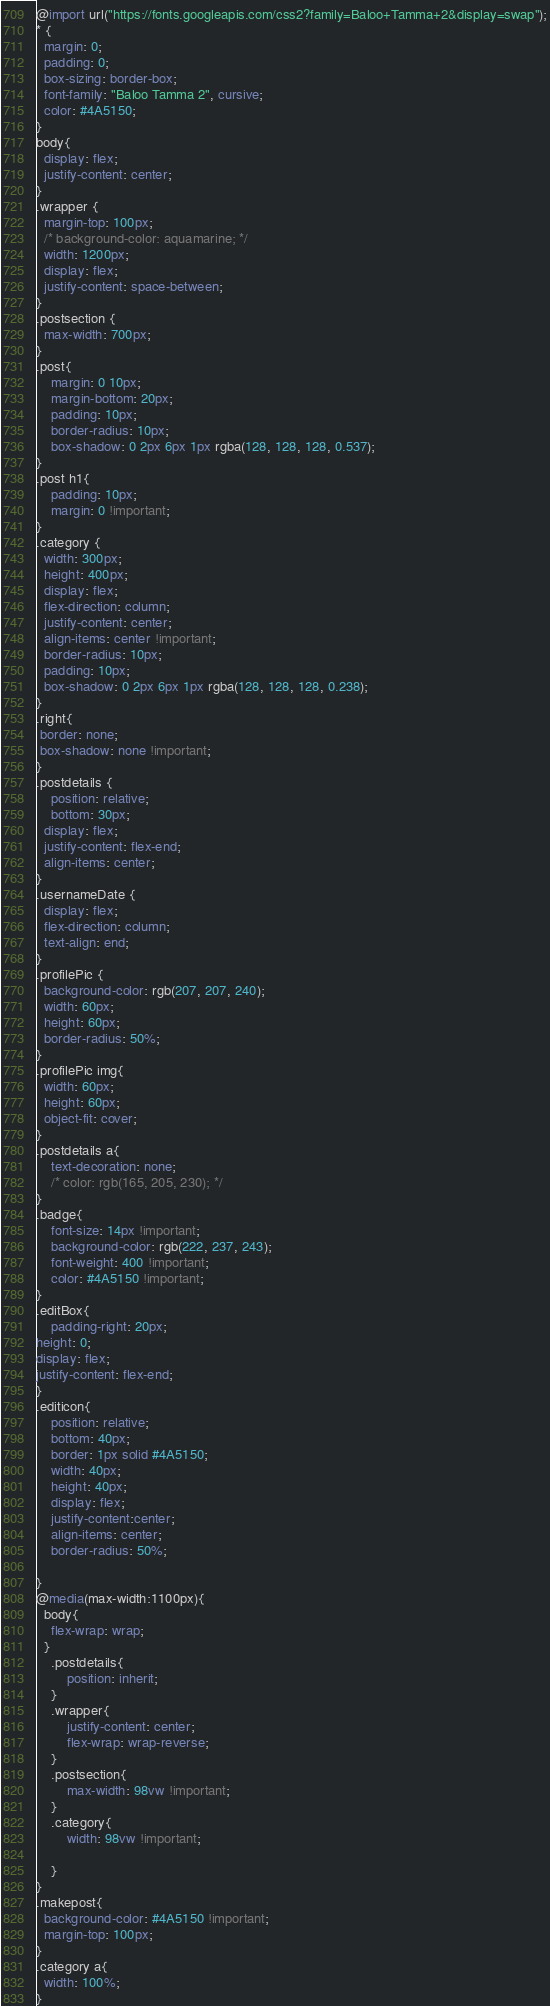Convert code to text. <code><loc_0><loc_0><loc_500><loc_500><_CSS_>@import url("https://fonts.googleapis.com/css2?family=Baloo+Tamma+2&display=swap");
* {
  margin: 0;
  padding: 0;
  box-sizing: border-box;
  font-family: "Baloo Tamma 2", cursive;
  color: #4A5150;
}
body{
  display: flex;
  justify-content: center;
}
.wrapper {
  margin-top: 100px;
  /* background-color: aquamarine; */
  width: 1200px;
  display: flex;
  justify-content: space-between;
}
.postsection {
  max-width: 700px;
}
.post{
    margin: 0 10px;
    margin-bottom: 20px;
    padding: 10px;
    border-radius: 10px;
    box-shadow: 0 2px 6px 1px rgba(128, 128, 128, 0.537);
}
.post h1{
    padding: 10px;
    margin: 0 !important;
}
.category {
  width: 300px;
  height: 400px;
  display: flex;
  flex-direction: column;
  justify-content: center;
  align-items: center !important;
  border-radius: 10px;
  padding: 10px;
  box-shadow: 0 2px 6px 1px rgba(128, 128, 128, 0.238);
}
.right{
 border: none;
 box-shadow: none !important;
}
.postdetails {
    position: relative;
    bottom: 30px;
  display: flex;
  justify-content: flex-end;
  align-items: center;
}
.usernameDate {
  display: flex;
  flex-direction: column;
  text-align: end;
}
.profilePic {
  background-color: rgb(207, 207, 240);
  width: 60px;
  height: 60px;
  border-radius: 50%;
}
.profilePic img{
  width: 60px;
  height: 60px;
  object-fit: cover;
}
.postdetails a{
    text-decoration: none;
    /* color: rgb(165, 205, 230); */
}
.badge{
    font-size: 14px !important;
    background-color: rgb(222, 237, 243);
    font-weight: 400 !important;
    color: #4A5150 !important;
}
.editBox{
    padding-right: 20px;
height: 0;
display: flex;
justify-content: flex-end;
}
.editicon{
    position: relative;
    bottom: 40px;
    border: 1px solid #4A5150;
    width: 40px;
    height: 40px;
    display: flex;
    justify-content:center;
    align-items: center;
    border-radius: 50%;
    
}
@media(max-width:1100px){
  body{
    flex-wrap: wrap;
  }
    .postdetails{
        position: inherit;
    }
    .wrapper{
        justify-content: center;
        flex-wrap: wrap-reverse;
    }
    .postsection{
        max-width: 98vw !important;
    }
    .category{
        width: 98vw !important;

    }
}
.makepost{
  background-color: #4A5150 !important;
  margin-top: 100px;
}
.category a{
  width: 100%;
}</code> 